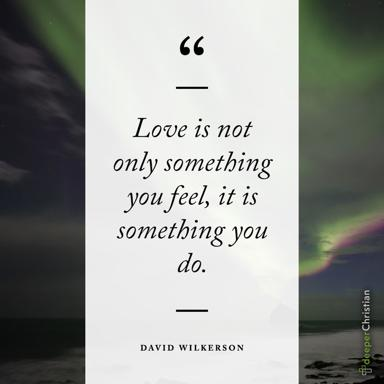What is the quote about love in the image? The quote in the image eloquently states, "Love is not only something you feel, it is something you do." This profound statement by David Wilkerson captures the essence of love as an active experience, not merely a passive emotion. It invites us to reflect on how love manifests through our actions towards others. 